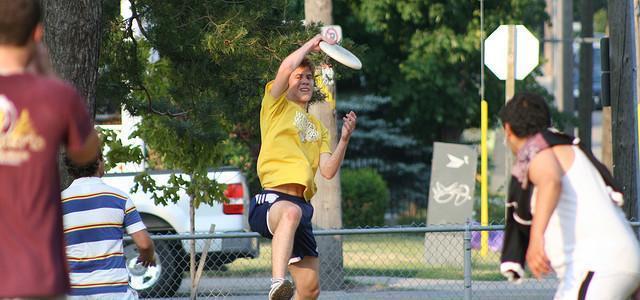How many people are in the picture?
Give a very brief answer. 4. How many toilets are in this bathroom?
Give a very brief answer. 0. 